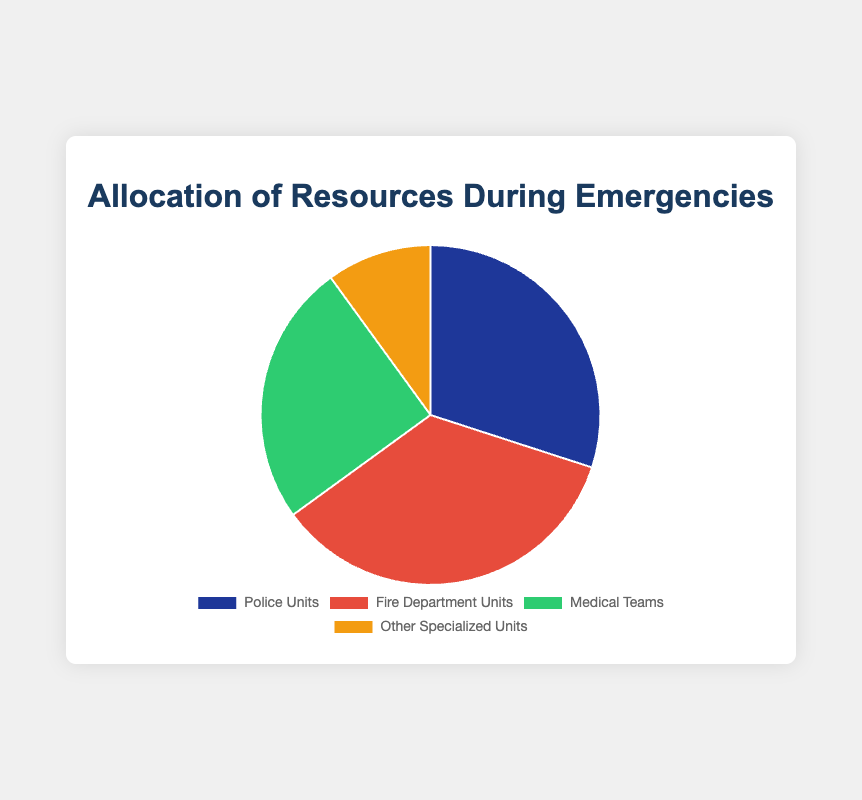Which unit has the largest allocation of resources during emergencies? The figure shows that Fire Department Units have the largest slice of the pie chart, corresponding to 35%.
Answer: Fire Department Units Which unit has the smallest allocation of resources during emergencies? The figure shows that Other Specialized Units have the smallest slice of the pie chart, corresponding to 10%.
Answer: Other Specialized Units How much larger is the allocation for Police Units compared to Other Specialized Units? The allocation for Police Units is 30% and for Other Specialized Units is 10%. The difference is 30% - 10% = 20%.
Answer: 20% What is the total allocation percentage for Police Units and Medical Teams combined? The allocation for Police Units is 30% and for Medical Teams is 25%. Their combined allocation is 30% + 25% = 55%.
Answer: 55% If we observe an increase of 5% in the allocation for Medical Teams, what would be the new allocation percentage for Medical Teams? The current allocation for Medical Teams is 25%. With an increase of 5%, the new allocation would be 25% + 5% = 30%.
Answer: 30% How does the allocation of resources for Fire Department Units compare with the combined allocation of Medical Teams and Other Specialized Units? Fire Department Units have an allocation of 35%. The combined allocation for Medical Teams (25%) and Other Specialized Units (10%) is 25% + 10% = 35%. Both values are equal.
Answer: Equal Which two units have the closest allocation percentages? The allocation for Police Units is 30% and Medical Teams is 25%. The difference is 5%. The allocation for Fire Department Units is 35%, and the allocation for Other Specialized Units is 10%, which makes a difference of 25%. Therefore, Police Units and Medical Teams have the closest allocation percentages.
Answer: Police Units and Medical Teams What is the average allocation percentage for all units? The percentages are Police Units 30%, Fire Department Units 35%, Medical Teams 25%, and Other Specialized Units 10%. The average allocation is (30% + 35% + 25% + 10%) / 4 = 100% / 4 = 25%.
Answer: 25% 